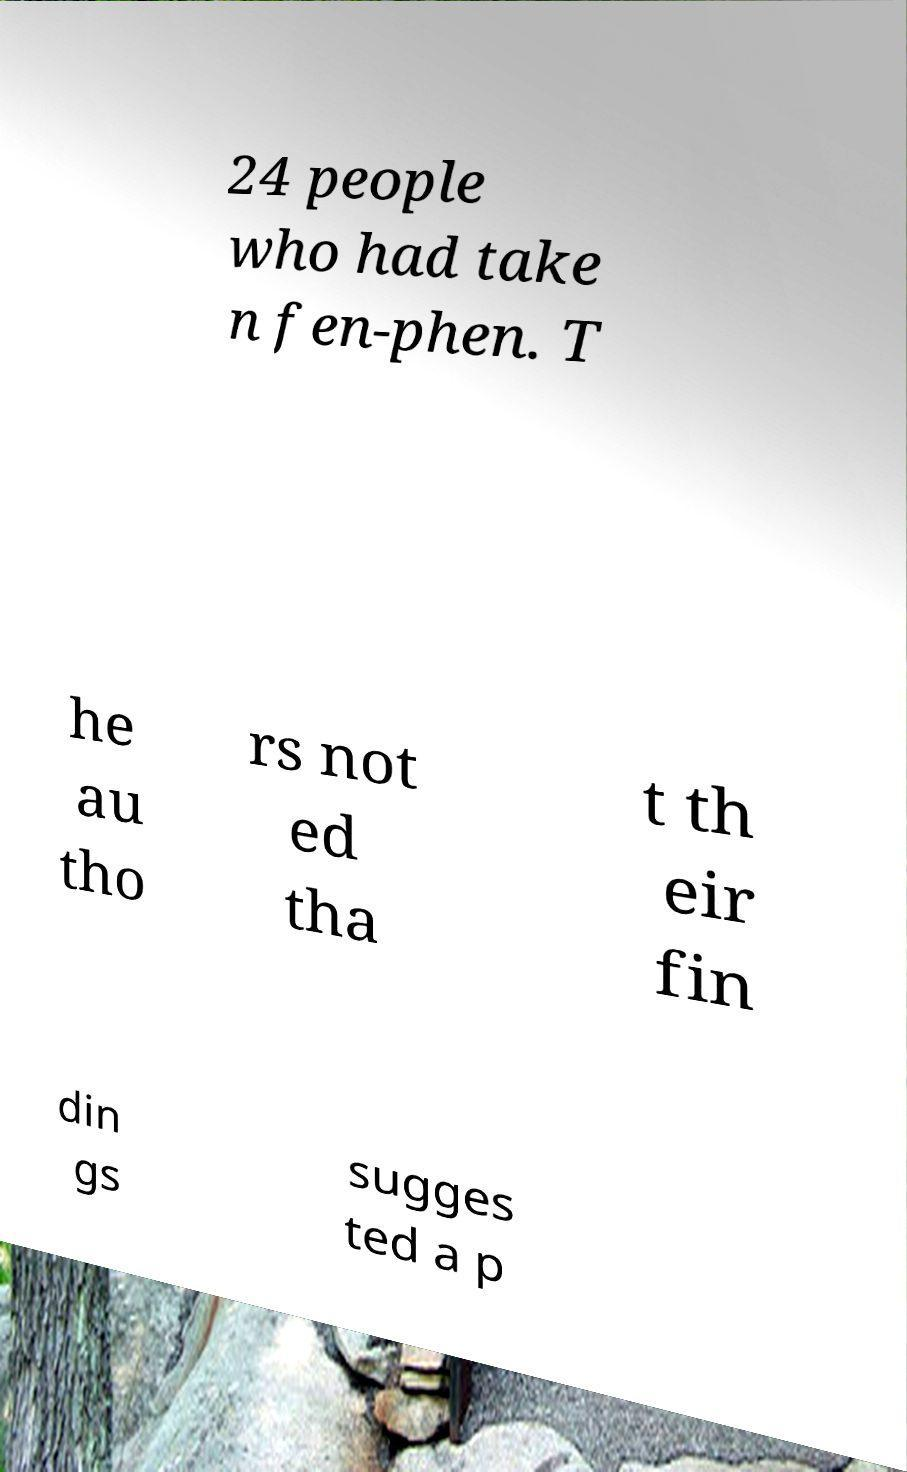I need the written content from this picture converted into text. Can you do that? 24 people who had take n fen-phen. T he au tho rs not ed tha t th eir fin din gs sugges ted a p 